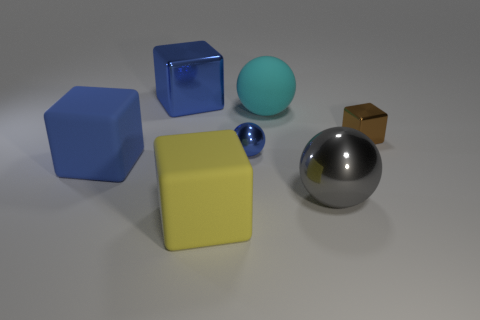Subtract all brown metal cubes. How many cubes are left? 3 Add 1 tiny green shiny cylinders. How many objects exist? 8 Add 1 big yellow things. How many big yellow things exist? 2 Subtract all blue balls. How many balls are left? 2 Subtract 1 cyan balls. How many objects are left? 6 Subtract all spheres. How many objects are left? 4 Subtract 2 spheres. How many spheres are left? 1 Subtract all purple blocks. Subtract all red spheres. How many blocks are left? 4 Subtract all blue cylinders. How many blue blocks are left? 2 Subtract all things. Subtract all red balls. How many objects are left? 0 